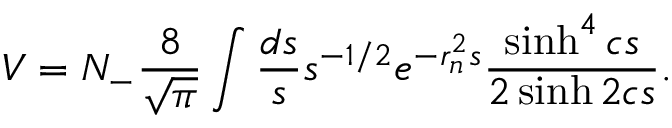<formula> <loc_0><loc_0><loc_500><loc_500>V = N _ { - } \frac { 8 } { \sqrt { \pi } } \int \frac { d s } { s } s ^ { - 1 / 2 } e ^ { - r _ { n } ^ { 2 } s } \frac { \sinh ^ { 4 } c s } { 2 \sinh 2 c s } .</formula> 